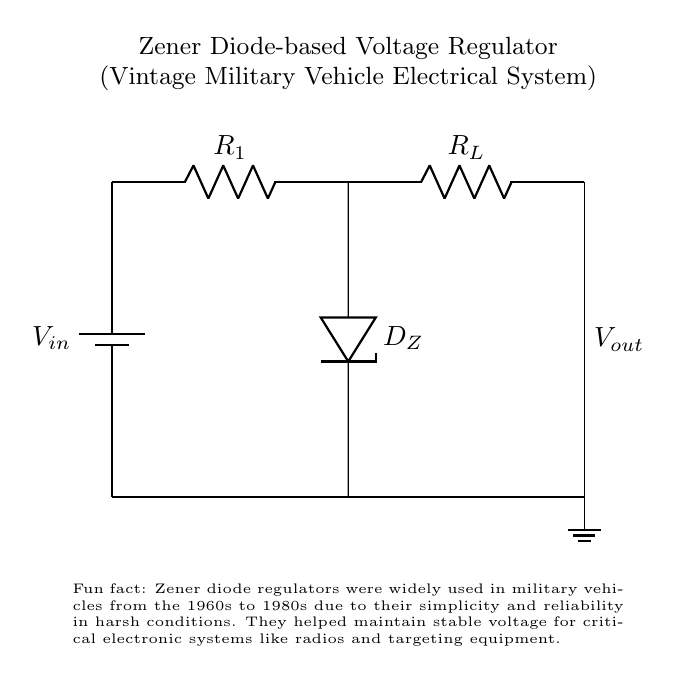What is the voltage source in this circuit? The voltage source is labeled as "Vin" and is represented by the battery symbol at the top left corner of the diagram. It's the component that supplies the electrical energy to the circuit.
Answer: Vin What component stabilizes the output voltage? The component that stabilizes the output voltage is the Zener diode, labeled as "D_Z" in the diagram. It allows current to flow in the reverse direction when the voltage exceeds a certain level, thereby maintaining a stable voltage across the load.
Answer: D_Z What does "Vout" indicate in this circuit? "Vout" indicates the output voltage across the load resistor "RL" at the right side of the circuit. This is the regulated voltage that can be used by the connected devices.
Answer: Vout What is the load resistor labeled in the circuit? The load resistor is labeled as "RL" in the circuit diagram. It is connected in parallel to the Zener diode and is the component that consumes the output voltage from the regulator.
Answer: RL How many resistors are present in this circuit? There are two resistors present in this circuit. One is "R1," which controls the current flowing into the Zener diode, and the other is "RL," which is the load resistor.
Answer: 2 What is the primary function of resistor R1? The primary function of resistor R1 is to limit the current flowing into the Zener diode, preventing it from exceeding its maximum current rating. This ensures the reliability and effective operation of the voltage regulation.
Answer: Limit current Why were Zener diode regulators favored in vintage military vehicles? Zener diode regulators were favored in vintage military vehicles due to their simplicity, reliability, and ability to maintain stable voltage in harsh conditions, which is crucial for critical electronic systems.
Answer: Simplicity and reliability 